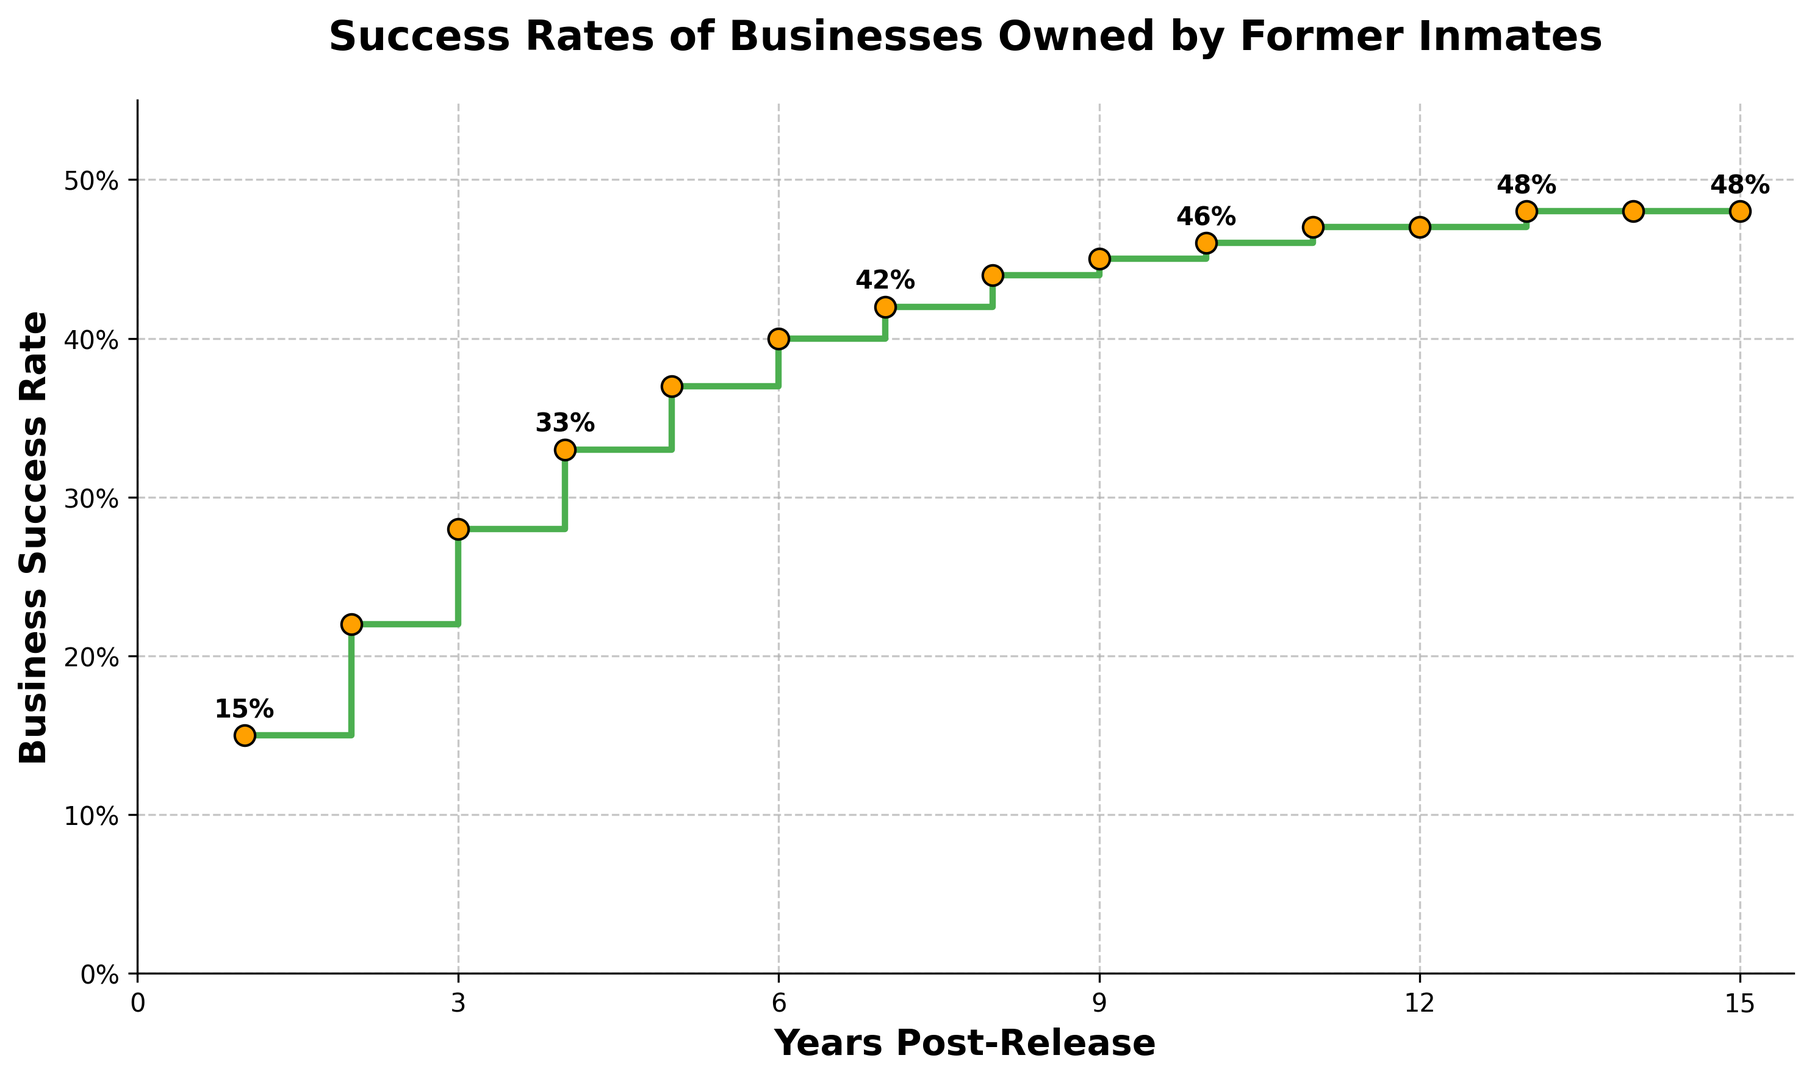what is the business success rate 5 years post-release? To find the success rate 5 years post-release, simply look up the rate corresponding to "Year = 5" on the plot.
Answer: 37% how does the business success rate at 10 years post-release compare to 1 year post-release? Find the success rates at 10 years and 1 year post-release on the plot. Compared to the success rate 1 year post-release (15%), the success rate at 10 years (46%) is higher.
Answer: Higher what is the average business success rate from 1 to 3 years post-release? Identify the success rates at 1, 2, and 3 years post-release, which are 15%, 22%, and 28%, respectively. Calculate the average: (15% + 22% + 28%) / 3 = 21.67%.
Answer: 21.67% between what years post-release does the business success rate increase the most? Observe the increases in success rates between consecutive years. The largest increase is between 1 and 2 years, where it increases from 15% to 22%.
Answer: Between 1 and 2 years what is the pattern of change in business success rates after year 10? After year 10, observe the plot and see that the success rate changes increase only slightly. At years 11, 12, and 13 it increases only by 1%, followed by no change at years 14 and 15.
Answer: Minimal increase and then stabilization what is the range of business success rate over 15 years post-release? The range is calculated by finding the difference between the maximum and minimum success rates over 15 years post-release. The maximum success rate is 48% and the minimum is 15%, so the range is 48% - 15% = 33%.
Answer: 33% how many years does it take for the business success rate to reach at least 40%? Identify the first year in which the success rate reaches 40% or higher. In year 6, the success rate is 40%, so it takes 6 years.
Answer: 6 years 